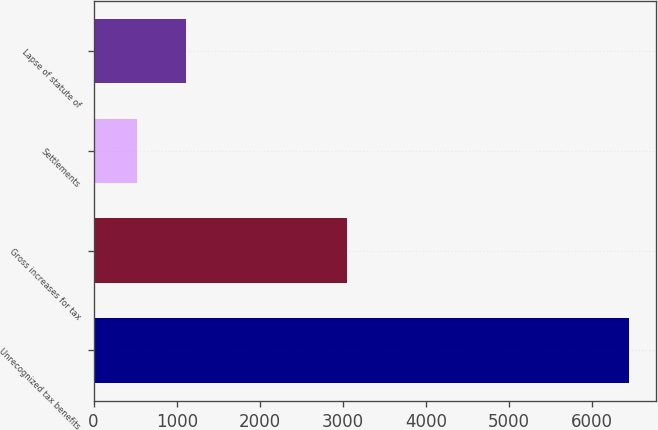Convert chart to OTSL. <chart><loc_0><loc_0><loc_500><loc_500><bar_chart><fcel>Unrecognized tax benefits<fcel>Gross increases for tax<fcel>Settlements<fcel>Lapse of statute of<nl><fcel>6440<fcel>3049<fcel>517<fcel>1109.3<nl></chart> 